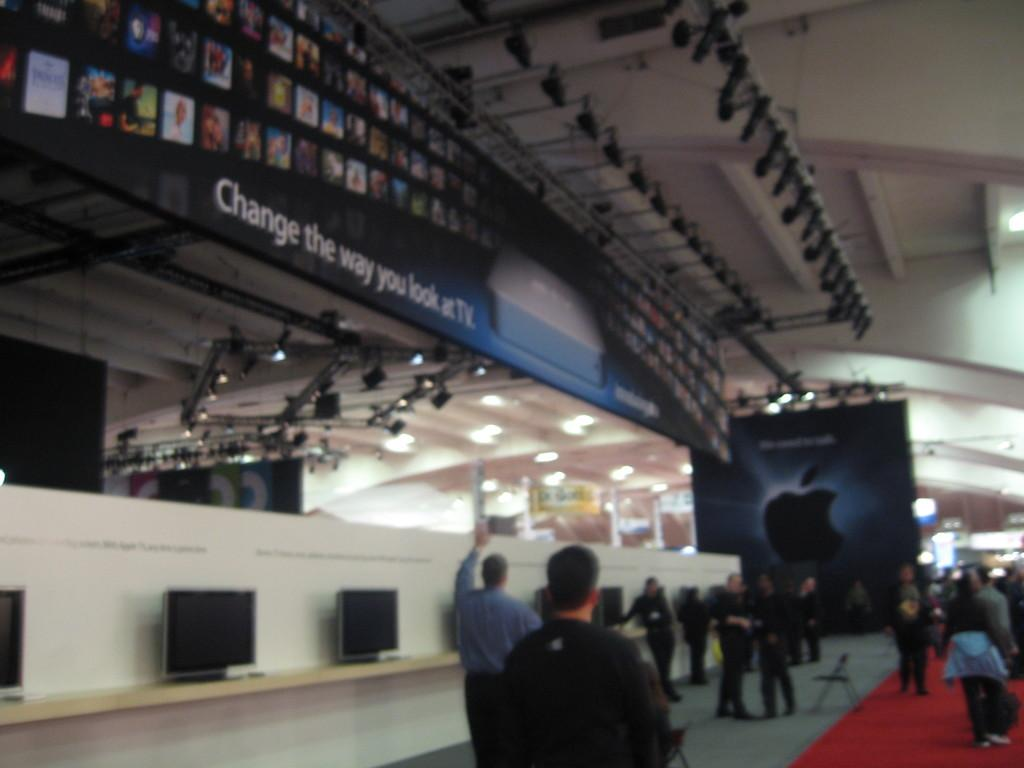What are the people in the image doing? The group of people is standing on the ground. What objects can be seen on a table in the background? There are monitors placed on a table in the background. What type of lighting is present in the background? There is a set of lights in the background. What can be seen on the walls in the background? There are hoardings in the background. What type of shoe is the person wearing in the image? There is no person wearing a shoe in the image; the group of people is standing on the ground without any visible footwear. 